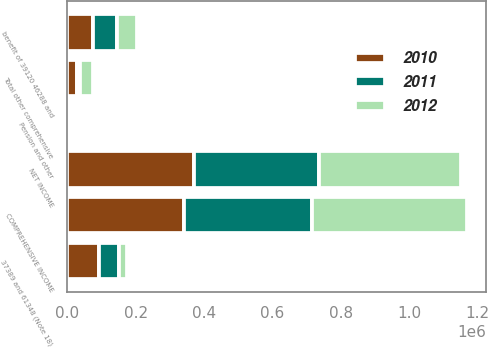Convert chart. <chart><loc_0><loc_0><loc_500><loc_500><stacked_bar_chart><ecel><fcel>NET INCOME<fcel>37389 and 61348 (Note 18)<fcel>benefit of 39120 46288 and<fcel>Pension and other<fcel>Total other comprehensive<fcel>COMPREHENSIVE INCOME<nl><fcel>2012<fcel>413164<fcel>22763<fcel>59887<fcel>1031<fcel>38155<fcel>451319<nl><fcel>2011<fcel>366940<fcel>57271<fcel>70902<fcel>6026<fcel>7605<fcel>374545<nl><fcel>2010<fcel>370209<fcel>93939<fcel>74287<fcel>8528<fcel>28180<fcel>342029<nl></chart> 